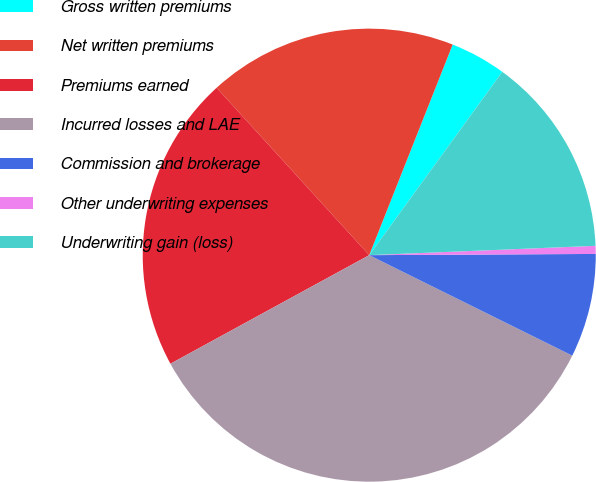Convert chart. <chart><loc_0><loc_0><loc_500><loc_500><pie_chart><fcel>Gross written premiums<fcel>Net written premiums<fcel>Premiums earned<fcel>Incurred losses and LAE<fcel>Commission and brokerage<fcel>Other underwriting expenses<fcel>Underwriting gain (loss)<nl><fcel>3.99%<fcel>17.77%<fcel>21.19%<fcel>34.73%<fcel>7.4%<fcel>0.57%<fcel>14.35%<nl></chart> 